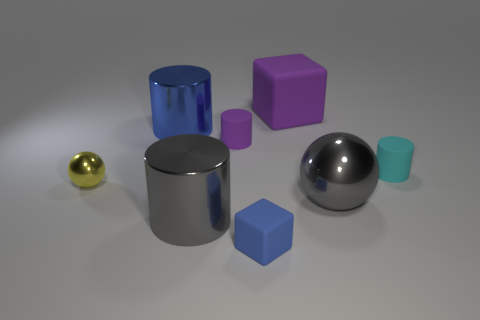Subtract all big blue metallic cylinders. How many cylinders are left? 3 Subtract 1 cylinders. How many cylinders are left? 3 Subtract all gray cylinders. How many cylinders are left? 3 Add 1 cylinders. How many objects exist? 9 Subtract all yellow cylinders. Subtract all brown cubes. How many cylinders are left? 4 Subtract all cubes. How many objects are left? 6 Subtract all cubes. Subtract all big gray cylinders. How many objects are left? 5 Add 4 small metallic balls. How many small metallic balls are left? 5 Add 2 large spheres. How many large spheres exist? 3 Subtract 0 cyan cubes. How many objects are left? 8 